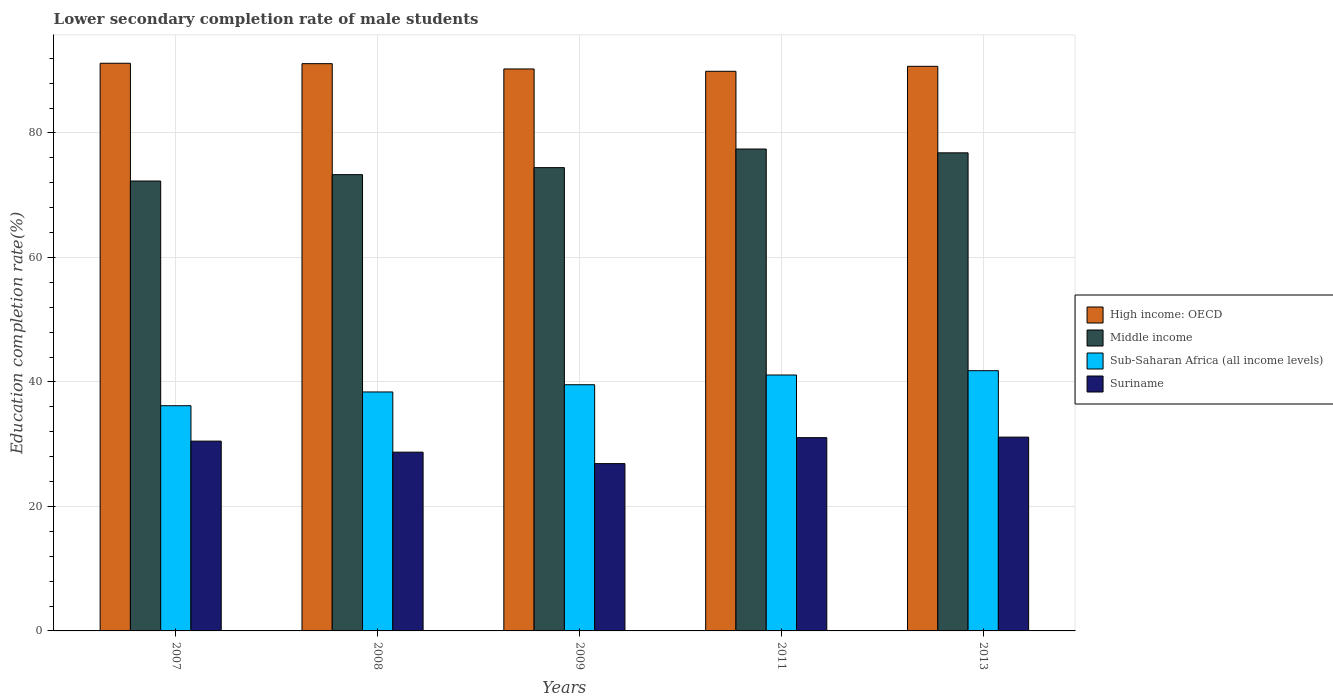How many different coloured bars are there?
Provide a short and direct response. 4. How many bars are there on the 1st tick from the left?
Provide a short and direct response. 4. How many bars are there on the 4th tick from the right?
Keep it short and to the point. 4. In how many cases, is the number of bars for a given year not equal to the number of legend labels?
Your answer should be very brief. 0. What is the lower secondary completion rate of male students in High income: OECD in 2009?
Provide a short and direct response. 90.28. Across all years, what is the maximum lower secondary completion rate of male students in Sub-Saharan Africa (all income levels)?
Give a very brief answer. 41.81. Across all years, what is the minimum lower secondary completion rate of male students in Sub-Saharan Africa (all income levels)?
Your answer should be very brief. 36.18. In which year was the lower secondary completion rate of male students in Sub-Saharan Africa (all income levels) maximum?
Provide a succinct answer. 2013. In which year was the lower secondary completion rate of male students in Suriname minimum?
Your answer should be very brief. 2009. What is the total lower secondary completion rate of male students in Sub-Saharan Africa (all income levels) in the graph?
Make the answer very short. 197.05. What is the difference between the lower secondary completion rate of male students in Middle income in 2008 and that in 2011?
Ensure brevity in your answer.  -4.12. What is the difference between the lower secondary completion rate of male students in Suriname in 2011 and the lower secondary completion rate of male students in Middle income in 2009?
Your response must be concise. -43.38. What is the average lower secondary completion rate of male students in Suriname per year?
Offer a terse response. 29.66. In the year 2007, what is the difference between the lower secondary completion rate of male students in Middle income and lower secondary completion rate of male students in High income: OECD?
Offer a terse response. -18.92. What is the ratio of the lower secondary completion rate of male students in Middle income in 2007 to that in 2009?
Provide a succinct answer. 0.97. What is the difference between the highest and the second highest lower secondary completion rate of male students in Sub-Saharan Africa (all income levels)?
Give a very brief answer. 0.69. What is the difference between the highest and the lowest lower secondary completion rate of male students in High income: OECD?
Give a very brief answer. 1.29. In how many years, is the lower secondary completion rate of male students in High income: OECD greater than the average lower secondary completion rate of male students in High income: OECD taken over all years?
Your answer should be very brief. 3. Is the sum of the lower secondary completion rate of male students in Suriname in 2007 and 2009 greater than the maximum lower secondary completion rate of male students in Sub-Saharan Africa (all income levels) across all years?
Your answer should be very brief. Yes. What does the 1st bar from the left in 2013 represents?
Your response must be concise. High income: OECD. What does the 4th bar from the right in 2009 represents?
Make the answer very short. High income: OECD. How many bars are there?
Your answer should be compact. 20. Are all the bars in the graph horizontal?
Give a very brief answer. No. How many years are there in the graph?
Offer a terse response. 5. Are the values on the major ticks of Y-axis written in scientific E-notation?
Offer a terse response. No. How many legend labels are there?
Give a very brief answer. 4. How are the legend labels stacked?
Make the answer very short. Vertical. What is the title of the graph?
Provide a short and direct response. Lower secondary completion rate of male students. What is the label or title of the X-axis?
Ensure brevity in your answer.  Years. What is the label or title of the Y-axis?
Offer a terse response. Education completion rate(%). What is the Education completion rate(%) in High income: OECD in 2007?
Offer a terse response. 91.2. What is the Education completion rate(%) in Middle income in 2007?
Your response must be concise. 72.28. What is the Education completion rate(%) in Sub-Saharan Africa (all income levels) in 2007?
Offer a terse response. 36.18. What is the Education completion rate(%) of Suriname in 2007?
Your answer should be very brief. 30.5. What is the Education completion rate(%) in High income: OECD in 2008?
Provide a short and direct response. 91.14. What is the Education completion rate(%) in Middle income in 2008?
Provide a short and direct response. 73.3. What is the Education completion rate(%) in Sub-Saharan Africa (all income levels) in 2008?
Ensure brevity in your answer.  38.39. What is the Education completion rate(%) of Suriname in 2008?
Keep it short and to the point. 28.72. What is the Education completion rate(%) in High income: OECD in 2009?
Offer a terse response. 90.28. What is the Education completion rate(%) of Middle income in 2009?
Provide a succinct answer. 74.43. What is the Education completion rate(%) in Sub-Saharan Africa (all income levels) in 2009?
Provide a succinct answer. 39.55. What is the Education completion rate(%) in Suriname in 2009?
Your answer should be compact. 26.88. What is the Education completion rate(%) of High income: OECD in 2011?
Offer a very short reply. 89.91. What is the Education completion rate(%) in Middle income in 2011?
Ensure brevity in your answer.  77.42. What is the Education completion rate(%) in Sub-Saharan Africa (all income levels) in 2011?
Provide a succinct answer. 41.12. What is the Education completion rate(%) in Suriname in 2011?
Keep it short and to the point. 31.05. What is the Education completion rate(%) of High income: OECD in 2013?
Provide a succinct answer. 90.71. What is the Education completion rate(%) in Middle income in 2013?
Provide a short and direct response. 76.81. What is the Education completion rate(%) of Sub-Saharan Africa (all income levels) in 2013?
Your answer should be very brief. 41.81. What is the Education completion rate(%) of Suriname in 2013?
Keep it short and to the point. 31.14. Across all years, what is the maximum Education completion rate(%) in High income: OECD?
Your answer should be very brief. 91.2. Across all years, what is the maximum Education completion rate(%) of Middle income?
Keep it short and to the point. 77.42. Across all years, what is the maximum Education completion rate(%) of Sub-Saharan Africa (all income levels)?
Ensure brevity in your answer.  41.81. Across all years, what is the maximum Education completion rate(%) in Suriname?
Your answer should be very brief. 31.14. Across all years, what is the minimum Education completion rate(%) of High income: OECD?
Offer a very short reply. 89.91. Across all years, what is the minimum Education completion rate(%) in Middle income?
Your answer should be compact. 72.28. Across all years, what is the minimum Education completion rate(%) of Sub-Saharan Africa (all income levels)?
Give a very brief answer. 36.18. Across all years, what is the minimum Education completion rate(%) of Suriname?
Provide a succinct answer. 26.88. What is the total Education completion rate(%) in High income: OECD in the graph?
Make the answer very short. 453.24. What is the total Education completion rate(%) of Middle income in the graph?
Provide a succinct answer. 374.25. What is the total Education completion rate(%) in Sub-Saharan Africa (all income levels) in the graph?
Ensure brevity in your answer.  197.05. What is the total Education completion rate(%) in Suriname in the graph?
Provide a succinct answer. 148.28. What is the difference between the Education completion rate(%) in High income: OECD in 2007 and that in 2008?
Your response must be concise. 0.07. What is the difference between the Education completion rate(%) in Middle income in 2007 and that in 2008?
Make the answer very short. -1.02. What is the difference between the Education completion rate(%) of Sub-Saharan Africa (all income levels) in 2007 and that in 2008?
Ensure brevity in your answer.  -2.21. What is the difference between the Education completion rate(%) in Suriname in 2007 and that in 2008?
Provide a short and direct response. 1.77. What is the difference between the Education completion rate(%) of High income: OECD in 2007 and that in 2009?
Your response must be concise. 0.92. What is the difference between the Education completion rate(%) of Middle income in 2007 and that in 2009?
Your response must be concise. -2.15. What is the difference between the Education completion rate(%) of Sub-Saharan Africa (all income levels) in 2007 and that in 2009?
Give a very brief answer. -3.37. What is the difference between the Education completion rate(%) of Suriname in 2007 and that in 2009?
Give a very brief answer. 3.62. What is the difference between the Education completion rate(%) of High income: OECD in 2007 and that in 2011?
Provide a succinct answer. 1.29. What is the difference between the Education completion rate(%) of Middle income in 2007 and that in 2011?
Ensure brevity in your answer.  -5.14. What is the difference between the Education completion rate(%) of Sub-Saharan Africa (all income levels) in 2007 and that in 2011?
Offer a very short reply. -4.94. What is the difference between the Education completion rate(%) in Suriname in 2007 and that in 2011?
Offer a terse response. -0.55. What is the difference between the Education completion rate(%) of High income: OECD in 2007 and that in 2013?
Make the answer very short. 0.49. What is the difference between the Education completion rate(%) of Middle income in 2007 and that in 2013?
Make the answer very short. -4.53. What is the difference between the Education completion rate(%) of Sub-Saharan Africa (all income levels) in 2007 and that in 2013?
Your answer should be very brief. -5.63. What is the difference between the Education completion rate(%) in Suriname in 2007 and that in 2013?
Ensure brevity in your answer.  -0.64. What is the difference between the Education completion rate(%) of High income: OECD in 2008 and that in 2009?
Your answer should be very brief. 0.85. What is the difference between the Education completion rate(%) in Middle income in 2008 and that in 2009?
Provide a succinct answer. -1.13. What is the difference between the Education completion rate(%) of Sub-Saharan Africa (all income levels) in 2008 and that in 2009?
Give a very brief answer. -1.16. What is the difference between the Education completion rate(%) of Suriname in 2008 and that in 2009?
Give a very brief answer. 1.84. What is the difference between the Education completion rate(%) of High income: OECD in 2008 and that in 2011?
Offer a very short reply. 1.22. What is the difference between the Education completion rate(%) of Middle income in 2008 and that in 2011?
Offer a very short reply. -4.12. What is the difference between the Education completion rate(%) in Sub-Saharan Africa (all income levels) in 2008 and that in 2011?
Ensure brevity in your answer.  -2.72. What is the difference between the Education completion rate(%) in Suriname in 2008 and that in 2011?
Your response must be concise. -2.33. What is the difference between the Education completion rate(%) of High income: OECD in 2008 and that in 2013?
Give a very brief answer. 0.43. What is the difference between the Education completion rate(%) in Middle income in 2008 and that in 2013?
Your answer should be very brief. -3.5. What is the difference between the Education completion rate(%) of Sub-Saharan Africa (all income levels) in 2008 and that in 2013?
Make the answer very short. -3.41. What is the difference between the Education completion rate(%) of Suriname in 2008 and that in 2013?
Keep it short and to the point. -2.42. What is the difference between the Education completion rate(%) in High income: OECD in 2009 and that in 2011?
Provide a succinct answer. 0.37. What is the difference between the Education completion rate(%) of Middle income in 2009 and that in 2011?
Your answer should be very brief. -2.99. What is the difference between the Education completion rate(%) of Sub-Saharan Africa (all income levels) in 2009 and that in 2011?
Make the answer very short. -1.56. What is the difference between the Education completion rate(%) in Suriname in 2009 and that in 2011?
Your answer should be compact. -4.17. What is the difference between the Education completion rate(%) of High income: OECD in 2009 and that in 2013?
Ensure brevity in your answer.  -0.43. What is the difference between the Education completion rate(%) in Middle income in 2009 and that in 2013?
Offer a very short reply. -2.38. What is the difference between the Education completion rate(%) in Sub-Saharan Africa (all income levels) in 2009 and that in 2013?
Your response must be concise. -2.25. What is the difference between the Education completion rate(%) in Suriname in 2009 and that in 2013?
Ensure brevity in your answer.  -4.26. What is the difference between the Education completion rate(%) of High income: OECD in 2011 and that in 2013?
Provide a short and direct response. -0.8. What is the difference between the Education completion rate(%) of Middle income in 2011 and that in 2013?
Give a very brief answer. 0.61. What is the difference between the Education completion rate(%) in Sub-Saharan Africa (all income levels) in 2011 and that in 2013?
Provide a short and direct response. -0.69. What is the difference between the Education completion rate(%) in Suriname in 2011 and that in 2013?
Keep it short and to the point. -0.09. What is the difference between the Education completion rate(%) in High income: OECD in 2007 and the Education completion rate(%) in Middle income in 2008?
Keep it short and to the point. 17.9. What is the difference between the Education completion rate(%) in High income: OECD in 2007 and the Education completion rate(%) in Sub-Saharan Africa (all income levels) in 2008?
Offer a very short reply. 52.81. What is the difference between the Education completion rate(%) in High income: OECD in 2007 and the Education completion rate(%) in Suriname in 2008?
Give a very brief answer. 62.48. What is the difference between the Education completion rate(%) in Middle income in 2007 and the Education completion rate(%) in Sub-Saharan Africa (all income levels) in 2008?
Provide a short and direct response. 33.89. What is the difference between the Education completion rate(%) of Middle income in 2007 and the Education completion rate(%) of Suriname in 2008?
Your answer should be very brief. 43.56. What is the difference between the Education completion rate(%) in Sub-Saharan Africa (all income levels) in 2007 and the Education completion rate(%) in Suriname in 2008?
Ensure brevity in your answer.  7.46. What is the difference between the Education completion rate(%) in High income: OECD in 2007 and the Education completion rate(%) in Middle income in 2009?
Ensure brevity in your answer.  16.77. What is the difference between the Education completion rate(%) in High income: OECD in 2007 and the Education completion rate(%) in Sub-Saharan Africa (all income levels) in 2009?
Provide a short and direct response. 51.65. What is the difference between the Education completion rate(%) in High income: OECD in 2007 and the Education completion rate(%) in Suriname in 2009?
Your answer should be very brief. 64.32. What is the difference between the Education completion rate(%) of Middle income in 2007 and the Education completion rate(%) of Sub-Saharan Africa (all income levels) in 2009?
Your answer should be compact. 32.73. What is the difference between the Education completion rate(%) of Middle income in 2007 and the Education completion rate(%) of Suriname in 2009?
Your answer should be very brief. 45.4. What is the difference between the Education completion rate(%) in Sub-Saharan Africa (all income levels) in 2007 and the Education completion rate(%) in Suriname in 2009?
Give a very brief answer. 9.3. What is the difference between the Education completion rate(%) in High income: OECD in 2007 and the Education completion rate(%) in Middle income in 2011?
Your answer should be compact. 13.78. What is the difference between the Education completion rate(%) of High income: OECD in 2007 and the Education completion rate(%) of Sub-Saharan Africa (all income levels) in 2011?
Your response must be concise. 50.08. What is the difference between the Education completion rate(%) in High income: OECD in 2007 and the Education completion rate(%) in Suriname in 2011?
Offer a very short reply. 60.15. What is the difference between the Education completion rate(%) in Middle income in 2007 and the Education completion rate(%) in Sub-Saharan Africa (all income levels) in 2011?
Your response must be concise. 31.16. What is the difference between the Education completion rate(%) in Middle income in 2007 and the Education completion rate(%) in Suriname in 2011?
Ensure brevity in your answer.  41.23. What is the difference between the Education completion rate(%) in Sub-Saharan Africa (all income levels) in 2007 and the Education completion rate(%) in Suriname in 2011?
Offer a very short reply. 5.13. What is the difference between the Education completion rate(%) in High income: OECD in 2007 and the Education completion rate(%) in Middle income in 2013?
Your answer should be very brief. 14.39. What is the difference between the Education completion rate(%) of High income: OECD in 2007 and the Education completion rate(%) of Sub-Saharan Africa (all income levels) in 2013?
Keep it short and to the point. 49.39. What is the difference between the Education completion rate(%) of High income: OECD in 2007 and the Education completion rate(%) of Suriname in 2013?
Your answer should be compact. 60.07. What is the difference between the Education completion rate(%) of Middle income in 2007 and the Education completion rate(%) of Sub-Saharan Africa (all income levels) in 2013?
Offer a terse response. 30.47. What is the difference between the Education completion rate(%) in Middle income in 2007 and the Education completion rate(%) in Suriname in 2013?
Make the answer very short. 41.15. What is the difference between the Education completion rate(%) in Sub-Saharan Africa (all income levels) in 2007 and the Education completion rate(%) in Suriname in 2013?
Ensure brevity in your answer.  5.05. What is the difference between the Education completion rate(%) of High income: OECD in 2008 and the Education completion rate(%) of Middle income in 2009?
Your answer should be compact. 16.7. What is the difference between the Education completion rate(%) of High income: OECD in 2008 and the Education completion rate(%) of Sub-Saharan Africa (all income levels) in 2009?
Your response must be concise. 51.58. What is the difference between the Education completion rate(%) of High income: OECD in 2008 and the Education completion rate(%) of Suriname in 2009?
Make the answer very short. 64.26. What is the difference between the Education completion rate(%) in Middle income in 2008 and the Education completion rate(%) in Sub-Saharan Africa (all income levels) in 2009?
Offer a terse response. 33.75. What is the difference between the Education completion rate(%) of Middle income in 2008 and the Education completion rate(%) of Suriname in 2009?
Your response must be concise. 46.42. What is the difference between the Education completion rate(%) in Sub-Saharan Africa (all income levels) in 2008 and the Education completion rate(%) in Suriname in 2009?
Your answer should be compact. 11.51. What is the difference between the Education completion rate(%) of High income: OECD in 2008 and the Education completion rate(%) of Middle income in 2011?
Your answer should be very brief. 13.71. What is the difference between the Education completion rate(%) of High income: OECD in 2008 and the Education completion rate(%) of Sub-Saharan Africa (all income levels) in 2011?
Your answer should be very brief. 50.02. What is the difference between the Education completion rate(%) in High income: OECD in 2008 and the Education completion rate(%) in Suriname in 2011?
Ensure brevity in your answer.  60.09. What is the difference between the Education completion rate(%) in Middle income in 2008 and the Education completion rate(%) in Sub-Saharan Africa (all income levels) in 2011?
Your response must be concise. 32.19. What is the difference between the Education completion rate(%) in Middle income in 2008 and the Education completion rate(%) in Suriname in 2011?
Make the answer very short. 42.26. What is the difference between the Education completion rate(%) of Sub-Saharan Africa (all income levels) in 2008 and the Education completion rate(%) of Suriname in 2011?
Provide a short and direct response. 7.34. What is the difference between the Education completion rate(%) in High income: OECD in 2008 and the Education completion rate(%) in Middle income in 2013?
Your answer should be compact. 14.33. What is the difference between the Education completion rate(%) of High income: OECD in 2008 and the Education completion rate(%) of Sub-Saharan Africa (all income levels) in 2013?
Provide a short and direct response. 49.33. What is the difference between the Education completion rate(%) of High income: OECD in 2008 and the Education completion rate(%) of Suriname in 2013?
Offer a very short reply. 60. What is the difference between the Education completion rate(%) of Middle income in 2008 and the Education completion rate(%) of Sub-Saharan Africa (all income levels) in 2013?
Keep it short and to the point. 31.5. What is the difference between the Education completion rate(%) of Middle income in 2008 and the Education completion rate(%) of Suriname in 2013?
Your answer should be very brief. 42.17. What is the difference between the Education completion rate(%) in Sub-Saharan Africa (all income levels) in 2008 and the Education completion rate(%) in Suriname in 2013?
Your response must be concise. 7.26. What is the difference between the Education completion rate(%) in High income: OECD in 2009 and the Education completion rate(%) in Middle income in 2011?
Keep it short and to the point. 12.86. What is the difference between the Education completion rate(%) of High income: OECD in 2009 and the Education completion rate(%) of Sub-Saharan Africa (all income levels) in 2011?
Provide a short and direct response. 49.17. What is the difference between the Education completion rate(%) of High income: OECD in 2009 and the Education completion rate(%) of Suriname in 2011?
Ensure brevity in your answer.  59.24. What is the difference between the Education completion rate(%) in Middle income in 2009 and the Education completion rate(%) in Sub-Saharan Africa (all income levels) in 2011?
Give a very brief answer. 33.31. What is the difference between the Education completion rate(%) in Middle income in 2009 and the Education completion rate(%) in Suriname in 2011?
Provide a succinct answer. 43.38. What is the difference between the Education completion rate(%) in Sub-Saharan Africa (all income levels) in 2009 and the Education completion rate(%) in Suriname in 2011?
Make the answer very short. 8.51. What is the difference between the Education completion rate(%) in High income: OECD in 2009 and the Education completion rate(%) in Middle income in 2013?
Make the answer very short. 13.48. What is the difference between the Education completion rate(%) of High income: OECD in 2009 and the Education completion rate(%) of Sub-Saharan Africa (all income levels) in 2013?
Ensure brevity in your answer.  48.48. What is the difference between the Education completion rate(%) of High income: OECD in 2009 and the Education completion rate(%) of Suriname in 2013?
Provide a succinct answer. 59.15. What is the difference between the Education completion rate(%) in Middle income in 2009 and the Education completion rate(%) in Sub-Saharan Africa (all income levels) in 2013?
Ensure brevity in your answer.  32.62. What is the difference between the Education completion rate(%) in Middle income in 2009 and the Education completion rate(%) in Suriname in 2013?
Provide a short and direct response. 43.3. What is the difference between the Education completion rate(%) of Sub-Saharan Africa (all income levels) in 2009 and the Education completion rate(%) of Suriname in 2013?
Ensure brevity in your answer.  8.42. What is the difference between the Education completion rate(%) in High income: OECD in 2011 and the Education completion rate(%) in Middle income in 2013?
Give a very brief answer. 13.1. What is the difference between the Education completion rate(%) of High income: OECD in 2011 and the Education completion rate(%) of Sub-Saharan Africa (all income levels) in 2013?
Give a very brief answer. 48.1. What is the difference between the Education completion rate(%) of High income: OECD in 2011 and the Education completion rate(%) of Suriname in 2013?
Keep it short and to the point. 58.78. What is the difference between the Education completion rate(%) of Middle income in 2011 and the Education completion rate(%) of Sub-Saharan Africa (all income levels) in 2013?
Offer a terse response. 35.62. What is the difference between the Education completion rate(%) of Middle income in 2011 and the Education completion rate(%) of Suriname in 2013?
Your answer should be very brief. 46.29. What is the difference between the Education completion rate(%) of Sub-Saharan Africa (all income levels) in 2011 and the Education completion rate(%) of Suriname in 2013?
Provide a succinct answer. 9.98. What is the average Education completion rate(%) in High income: OECD per year?
Ensure brevity in your answer.  90.65. What is the average Education completion rate(%) in Middle income per year?
Make the answer very short. 74.85. What is the average Education completion rate(%) of Sub-Saharan Africa (all income levels) per year?
Offer a terse response. 39.41. What is the average Education completion rate(%) of Suriname per year?
Your answer should be compact. 29.66. In the year 2007, what is the difference between the Education completion rate(%) in High income: OECD and Education completion rate(%) in Middle income?
Give a very brief answer. 18.92. In the year 2007, what is the difference between the Education completion rate(%) of High income: OECD and Education completion rate(%) of Sub-Saharan Africa (all income levels)?
Your answer should be compact. 55.02. In the year 2007, what is the difference between the Education completion rate(%) in High income: OECD and Education completion rate(%) in Suriname?
Your answer should be compact. 60.71. In the year 2007, what is the difference between the Education completion rate(%) in Middle income and Education completion rate(%) in Sub-Saharan Africa (all income levels)?
Provide a short and direct response. 36.1. In the year 2007, what is the difference between the Education completion rate(%) in Middle income and Education completion rate(%) in Suriname?
Offer a very short reply. 41.79. In the year 2007, what is the difference between the Education completion rate(%) in Sub-Saharan Africa (all income levels) and Education completion rate(%) in Suriname?
Keep it short and to the point. 5.69. In the year 2008, what is the difference between the Education completion rate(%) of High income: OECD and Education completion rate(%) of Middle income?
Your answer should be very brief. 17.83. In the year 2008, what is the difference between the Education completion rate(%) of High income: OECD and Education completion rate(%) of Sub-Saharan Africa (all income levels)?
Your response must be concise. 52.74. In the year 2008, what is the difference between the Education completion rate(%) of High income: OECD and Education completion rate(%) of Suriname?
Make the answer very short. 62.42. In the year 2008, what is the difference between the Education completion rate(%) in Middle income and Education completion rate(%) in Sub-Saharan Africa (all income levels)?
Offer a terse response. 34.91. In the year 2008, what is the difference between the Education completion rate(%) of Middle income and Education completion rate(%) of Suriname?
Offer a very short reply. 44.58. In the year 2008, what is the difference between the Education completion rate(%) of Sub-Saharan Africa (all income levels) and Education completion rate(%) of Suriname?
Offer a terse response. 9.67. In the year 2009, what is the difference between the Education completion rate(%) in High income: OECD and Education completion rate(%) in Middle income?
Make the answer very short. 15.85. In the year 2009, what is the difference between the Education completion rate(%) in High income: OECD and Education completion rate(%) in Sub-Saharan Africa (all income levels)?
Provide a succinct answer. 50.73. In the year 2009, what is the difference between the Education completion rate(%) of High income: OECD and Education completion rate(%) of Suriname?
Offer a very short reply. 63.4. In the year 2009, what is the difference between the Education completion rate(%) of Middle income and Education completion rate(%) of Sub-Saharan Africa (all income levels)?
Keep it short and to the point. 34.88. In the year 2009, what is the difference between the Education completion rate(%) in Middle income and Education completion rate(%) in Suriname?
Offer a very short reply. 47.55. In the year 2009, what is the difference between the Education completion rate(%) in Sub-Saharan Africa (all income levels) and Education completion rate(%) in Suriname?
Offer a very short reply. 12.67. In the year 2011, what is the difference between the Education completion rate(%) of High income: OECD and Education completion rate(%) of Middle income?
Your answer should be very brief. 12.49. In the year 2011, what is the difference between the Education completion rate(%) in High income: OECD and Education completion rate(%) in Sub-Saharan Africa (all income levels)?
Give a very brief answer. 48.79. In the year 2011, what is the difference between the Education completion rate(%) in High income: OECD and Education completion rate(%) in Suriname?
Make the answer very short. 58.86. In the year 2011, what is the difference between the Education completion rate(%) of Middle income and Education completion rate(%) of Sub-Saharan Africa (all income levels)?
Ensure brevity in your answer.  36.31. In the year 2011, what is the difference between the Education completion rate(%) of Middle income and Education completion rate(%) of Suriname?
Provide a succinct answer. 46.38. In the year 2011, what is the difference between the Education completion rate(%) of Sub-Saharan Africa (all income levels) and Education completion rate(%) of Suriname?
Your answer should be very brief. 10.07. In the year 2013, what is the difference between the Education completion rate(%) in High income: OECD and Education completion rate(%) in Middle income?
Make the answer very short. 13.9. In the year 2013, what is the difference between the Education completion rate(%) of High income: OECD and Education completion rate(%) of Sub-Saharan Africa (all income levels)?
Provide a short and direct response. 48.9. In the year 2013, what is the difference between the Education completion rate(%) of High income: OECD and Education completion rate(%) of Suriname?
Provide a succinct answer. 59.57. In the year 2013, what is the difference between the Education completion rate(%) of Middle income and Education completion rate(%) of Sub-Saharan Africa (all income levels)?
Your response must be concise. 35. In the year 2013, what is the difference between the Education completion rate(%) of Middle income and Education completion rate(%) of Suriname?
Your response must be concise. 45.67. In the year 2013, what is the difference between the Education completion rate(%) of Sub-Saharan Africa (all income levels) and Education completion rate(%) of Suriname?
Your answer should be very brief. 10.67. What is the ratio of the Education completion rate(%) in Middle income in 2007 to that in 2008?
Your answer should be compact. 0.99. What is the ratio of the Education completion rate(%) in Sub-Saharan Africa (all income levels) in 2007 to that in 2008?
Your answer should be very brief. 0.94. What is the ratio of the Education completion rate(%) of Suriname in 2007 to that in 2008?
Offer a very short reply. 1.06. What is the ratio of the Education completion rate(%) in High income: OECD in 2007 to that in 2009?
Ensure brevity in your answer.  1.01. What is the ratio of the Education completion rate(%) of Middle income in 2007 to that in 2009?
Provide a short and direct response. 0.97. What is the ratio of the Education completion rate(%) in Sub-Saharan Africa (all income levels) in 2007 to that in 2009?
Your answer should be compact. 0.91. What is the ratio of the Education completion rate(%) of Suriname in 2007 to that in 2009?
Your response must be concise. 1.13. What is the ratio of the Education completion rate(%) of High income: OECD in 2007 to that in 2011?
Keep it short and to the point. 1.01. What is the ratio of the Education completion rate(%) of Middle income in 2007 to that in 2011?
Your answer should be very brief. 0.93. What is the ratio of the Education completion rate(%) of Sub-Saharan Africa (all income levels) in 2007 to that in 2011?
Give a very brief answer. 0.88. What is the ratio of the Education completion rate(%) of Suriname in 2007 to that in 2011?
Your response must be concise. 0.98. What is the ratio of the Education completion rate(%) of High income: OECD in 2007 to that in 2013?
Provide a succinct answer. 1.01. What is the ratio of the Education completion rate(%) in Middle income in 2007 to that in 2013?
Make the answer very short. 0.94. What is the ratio of the Education completion rate(%) in Sub-Saharan Africa (all income levels) in 2007 to that in 2013?
Provide a succinct answer. 0.87. What is the ratio of the Education completion rate(%) in Suriname in 2007 to that in 2013?
Provide a succinct answer. 0.98. What is the ratio of the Education completion rate(%) in High income: OECD in 2008 to that in 2009?
Provide a short and direct response. 1.01. What is the ratio of the Education completion rate(%) in Middle income in 2008 to that in 2009?
Give a very brief answer. 0.98. What is the ratio of the Education completion rate(%) in Sub-Saharan Africa (all income levels) in 2008 to that in 2009?
Your answer should be very brief. 0.97. What is the ratio of the Education completion rate(%) in Suriname in 2008 to that in 2009?
Offer a very short reply. 1.07. What is the ratio of the Education completion rate(%) of High income: OECD in 2008 to that in 2011?
Keep it short and to the point. 1.01. What is the ratio of the Education completion rate(%) in Middle income in 2008 to that in 2011?
Your response must be concise. 0.95. What is the ratio of the Education completion rate(%) in Sub-Saharan Africa (all income levels) in 2008 to that in 2011?
Make the answer very short. 0.93. What is the ratio of the Education completion rate(%) in Suriname in 2008 to that in 2011?
Make the answer very short. 0.93. What is the ratio of the Education completion rate(%) of High income: OECD in 2008 to that in 2013?
Offer a terse response. 1. What is the ratio of the Education completion rate(%) of Middle income in 2008 to that in 2013?
Your answer should be compact. 0.95. What is the ratio of the Education completion rate(%) in Sub-Saharan Africa (all income levels) in 2008 to that in 2013?
Your answer should be compact. 0.92. What is the ratio of the Education completion rate(%) of Suriname in 2008 to that in 2013?
Your response must be concise. 0.92. What is the ratio of the Education completion rate(%) in Middle income in 2009 to that in 2011?
Offer a terse response. 0.96. What is the ratio of the Education completion rate(%) in Suriname in 2009 to that in 2011?
Your answer should be compact. 0.87. What is the ratio of the Education completion rate(%) of Middle income in 2009 to that in 2013?
Your answer should be compact. 0.97. What is the ratio of the Education completion rate(%) in Sub-Saharan Africa (all income levels) in 2009 to that in 2013?
Keep it short and to the point. 0.95. What is the ratio of the Education completion rate(%) in Suriname in 2009 to that in 2013?
Offer a terse response. 0.86. What is the ratio of the Education completion rate(%) in Middle income in 2011 to that in 2013?
Offer a very short reply. 1.01. What is the ratio of the Education completion rate(%) of Sub-Saharan Africa (all income levels) in 2011 to that in 2013?
Give a very brief answer. 0.98. What is the ratio of the Education completion rate(%) of Suriname in 2011 to that in 2013?
Provide a short and direct response. 1. What is the difference between the highest and the second highest Education completion rate(%) of High income: OECD?
Offer a very short reply. 0.07. What is the difference between the highest and the second highest Education completion rate(%) of Middle income?
Ensure brevity in your answer.  0.61. What is the difference between the highest and the second highest Education completion rate(%) of Sub-Saharan Africa (all income levels)?
Offer a very short reply. 0.69. What is the difference between the highest and the second highest Education completion rate(%) of Suriname?
Offer a very short reply. 0.09. What is the difference between the highest and the lowest Education completion rate(%) in High income: OECD?
Make the answer very short. 1.29. What is the difference between the highest and the lowest Education completion rate(%) of Middle income?
Offer a very short reply. 5.14. What is the difference between the highest and the lowest Education completion rate(%) in Sub-Saharan Africa (all income levels)?
Provide a succinct answer. 5.63. What is the difference between the highest and the lowest Education completion rate(%) in Suriname?
Offer a terse response. 4.26. 